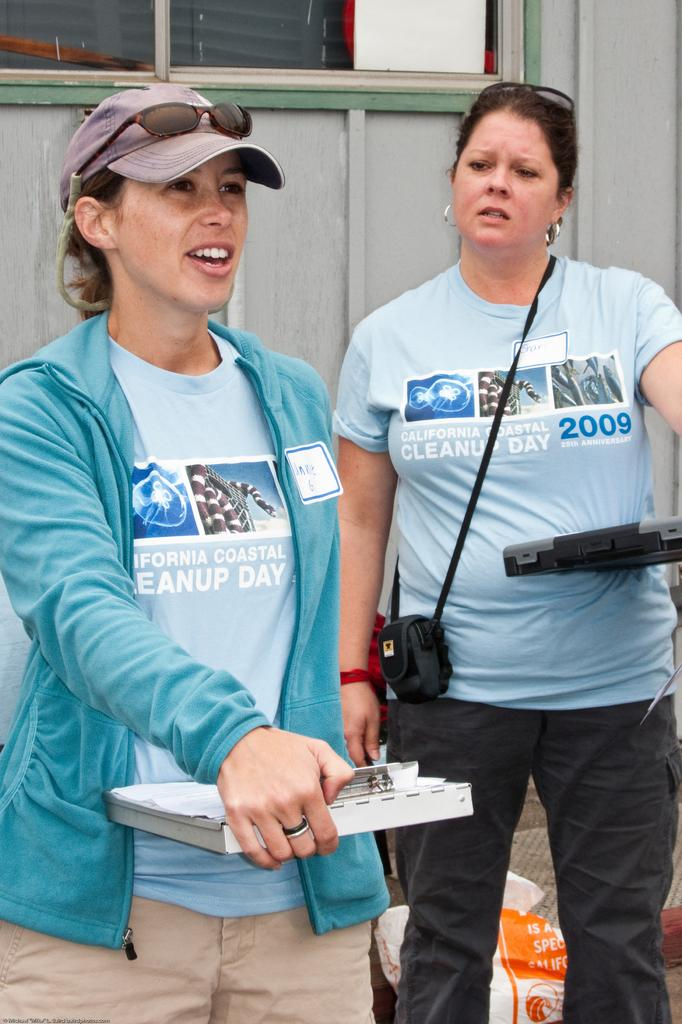<image>
Share a concise interpretation of the image provided. Two women wearing blue California Coastal Cleanup Day t-shirts. 